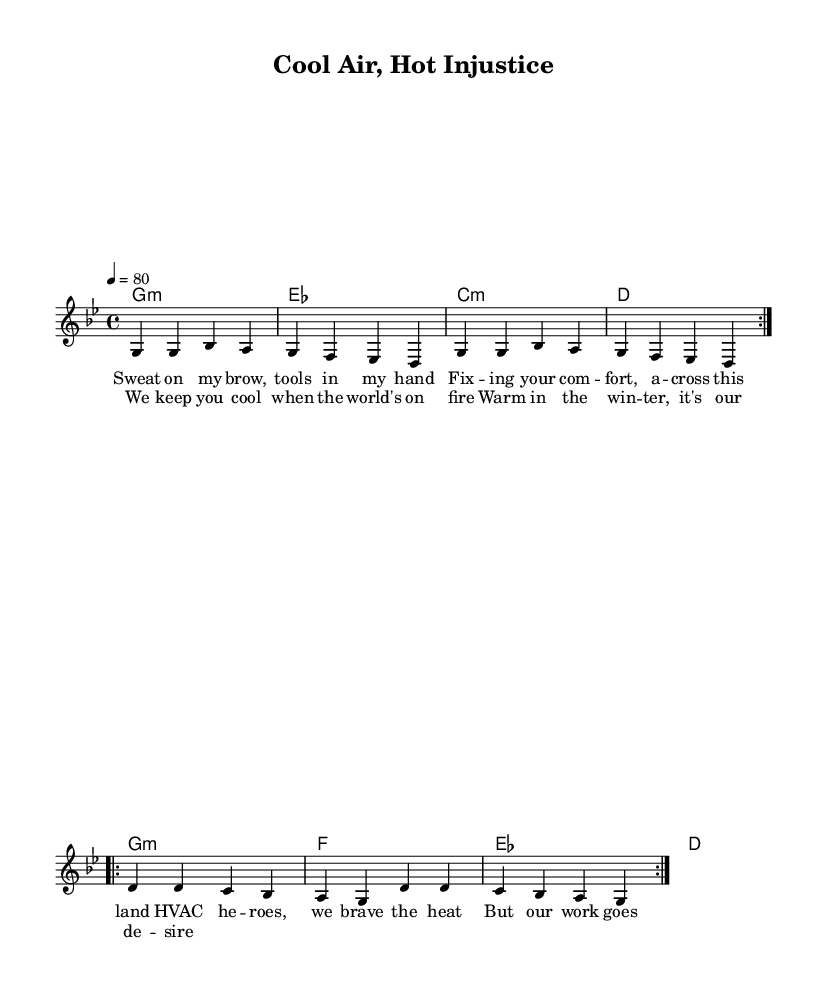What is the key signature of this music? The key signature is G minor, which has two flats (B and E). This can be identified at the beginning of the staff where the flats are indicated.
Answer: G minor What is the time signature of this music? The time signature is 4/4, which means there are four beats in each measure, and the quarter note gets one beat. This is shown at the beginning of the music following the key signature.
Answer: 4/4 What is the tempo marking of this piece? The tempo marking is 80 beats per minute, indicated by the number 4 = 80 written at the beginning of the score. This specifies the speed at which the piece should be played.
Answer: 80 How many verses does the song contain? The song contains one verse based on the lyrics provided, which are under the main melody section labeled as verseOne. This indicates a single set of lyrics corresponding to the melody without additional verses present.
Answer: One What genre is this piece? The genre is reggae, which can be inferred from the song title "Cool Air, Hot Injustice" and the context of the lyrics that speaks to social issues in a reggae style.
Answer: Reggae What is the emotional theme of the lyrics? The emotional theme revolves around the struggle and underappreciation of essential workers, specifically HVAC technicians, emphasizing their hard work and dedication despite lack of recognition. This can be identified through key phrases in the lyrics.
Answer: Underappreciation What is the primary message conveyed in the chorus? The primary message of the chorus is to highlight the essential role of workers in providing comfort to others, even in challenging conditions, framing it as a desire to be appreciated for their work. This is evident in the repetition and sentiment expressed in the lyrics.
Answer: Essential worker recognition 